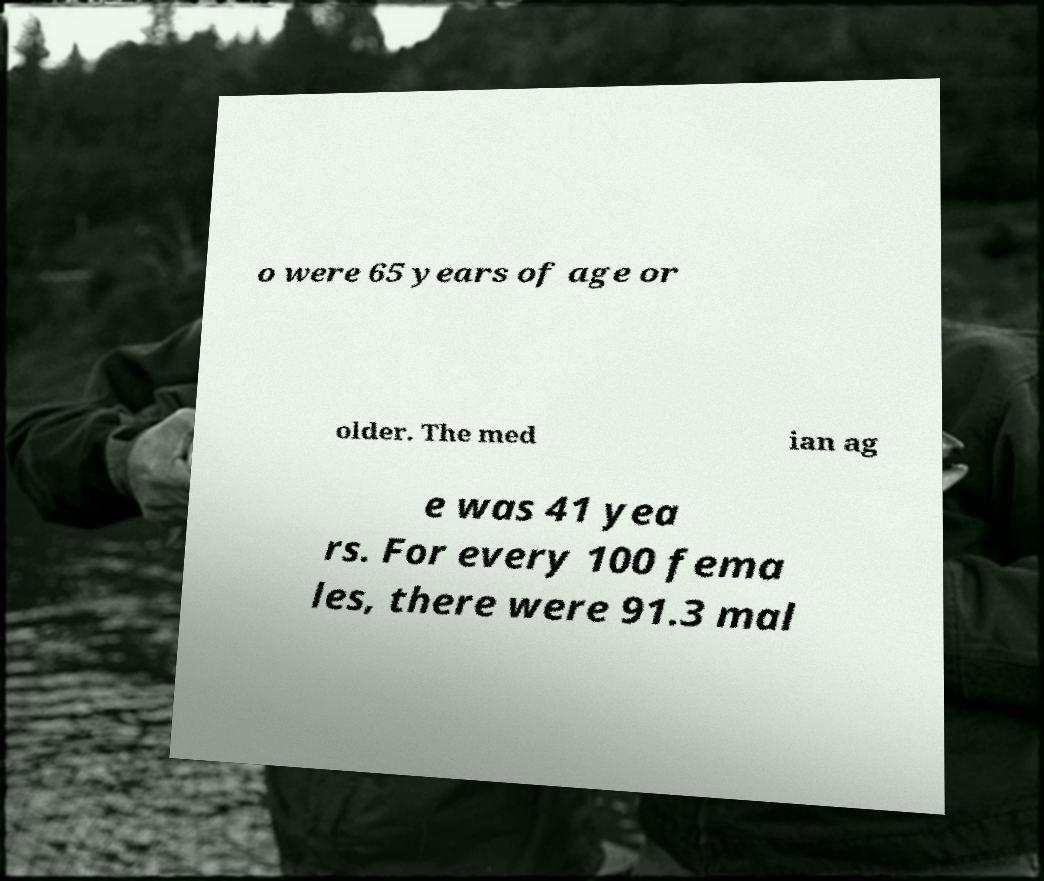I need the written content from this picture converted into text. Can you do that? o were 65 years of age or older. The med ian ag e was 41 yea rs. For every 100 fema les, there were 91.3 mal 